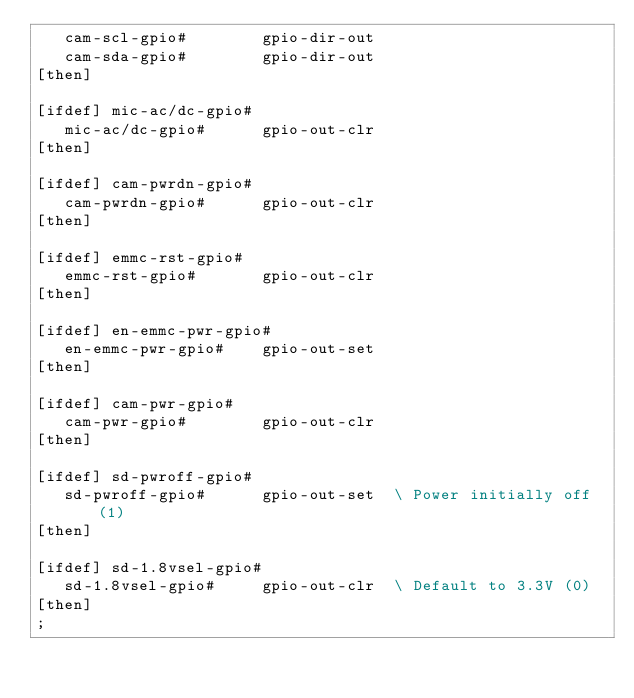<code> <loc_0><loc_0><loc_500><loc_500><_Forth_>   cam-scl-gpio#        gpio-dir-out
   cam-sda-gpio#        gpio-dir-out
[then]

[ifdef] mic-ac/dc-gpio#
   mic-ac/dc-gpio#      gpio-out-clr
[then]

[ifdef] cam-pwrdn-gpio#
   cam-pwrdn-gpio#      gpio-out-clr
[then]

[ifdef] emmc-rst-gpio#
   emmc-rst-gpio#       gpio-out-clr
[then]

[ifdef] en-emmc-pwr-gpio#
   en-emmc-pwr-gpio#    gpio-out-set
[then]

[ifdef] cam-pwr-gpio#
   cam-pwr-gpio#        gpio-out-clr
[then]

[ifdef] sd-pwroff-gpio#
   sd-pwroff-gpio#      gpio-out-set  \ Power initially off (1)
[then]

[ifdef] sd-1.8vsel-gpio#
   sd-1.8vsel-gpio#     gpio-out-clr  \ Default to 3.3V (0)
[then]
;
</code> 